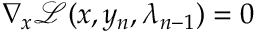<formula> <loc_0><loc_0><loc_500><loc_500>\nabla _ { x } \mathcal { L } ( x , y _ { n } , \lambda _ { n - 1 } ) = 0</formula> 